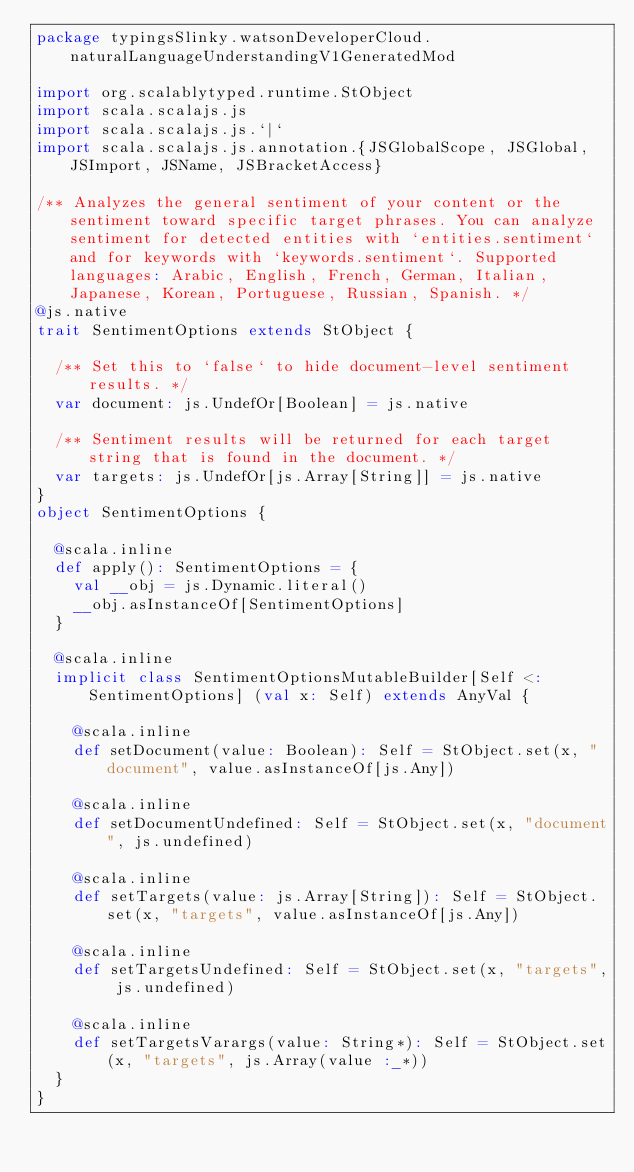Convert code to text. <code><loc_0><loc_0><loc_500><loc_500><_Scala_>package typingsSlinky.watsonDeveloperCloud.naturalLanguageUnderstandingV1GeneratedMod

import org.scalablytyped.runtime.StObject
import scala.scalajs.js
import scala.scalajs.js.`|`
import scala.scalajs.js.annotation.{JSGlobalScope, JSGlobal, JSImport, JSName, JSBracketAccess}

/** Analyzes the general sentiment of your content or the sentiment toward specific target phrases. You can analyze sentiment for detected entities with `entities.sentiment` and for keywords with `keywords.sentiment`. Supported languages: Arabic, English, French, German, Italian, Japanese, Korean, Portuguese, Russian, Spanish. */
@js.native
trait SentimentOptions extends StObject {
  
  /** Set this to `false` to hide document-level sentiment results. */
  var document: js.UndefOr[Boolean] = js.native
  
  /** Sentiment results will be returned for each target string that is found in the document. */
  var targets: js.UndefOr[js.Array[String]] = js.native
}
object SentimentOptions {
  
  @scala.inline
  def apply(): SentimentOptions = {
    val __obj = js.Dynamic.literal()
    __obj.asInstanceOf[SentimentOptions]
  }
  
  @scala.inline
  implicit class SentimentOptionsMutableBuilder[Self <: SentimentOptions] (val x: Self) extends AnyVal {
    
    @scala.inline
    def setDocument(value: Boolean): Self = StObject.set(x, "document", value.asInstanceOf[js.Any])
    
    @scala.inline
    def setDocumentUndefined: Self = StObject.set(x, "document", js.undefined)
    
    @scala.inline
    def setTargets(value: js.Array[String]): Self = StObject.set(x, "targets", value.asInstanceOf[js.Any])
    
    @scala.inline
    def setTargetsUndefined: Self = StObject.set(x, "targets", js.undefined)
    
    @scala.inline
    def setTargetsVarargs(value: String*): Self = StObject.set(x, "targets", js.Array(value :_*))
  }
}
</code> 